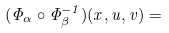<formula> <loc_0><loc_0><loc_500><loc_500>( \Phi _ { \alpha } \circ \Phi _ { \beta } ^ { - 1 } ) ( x , u , v ) =</formula> 